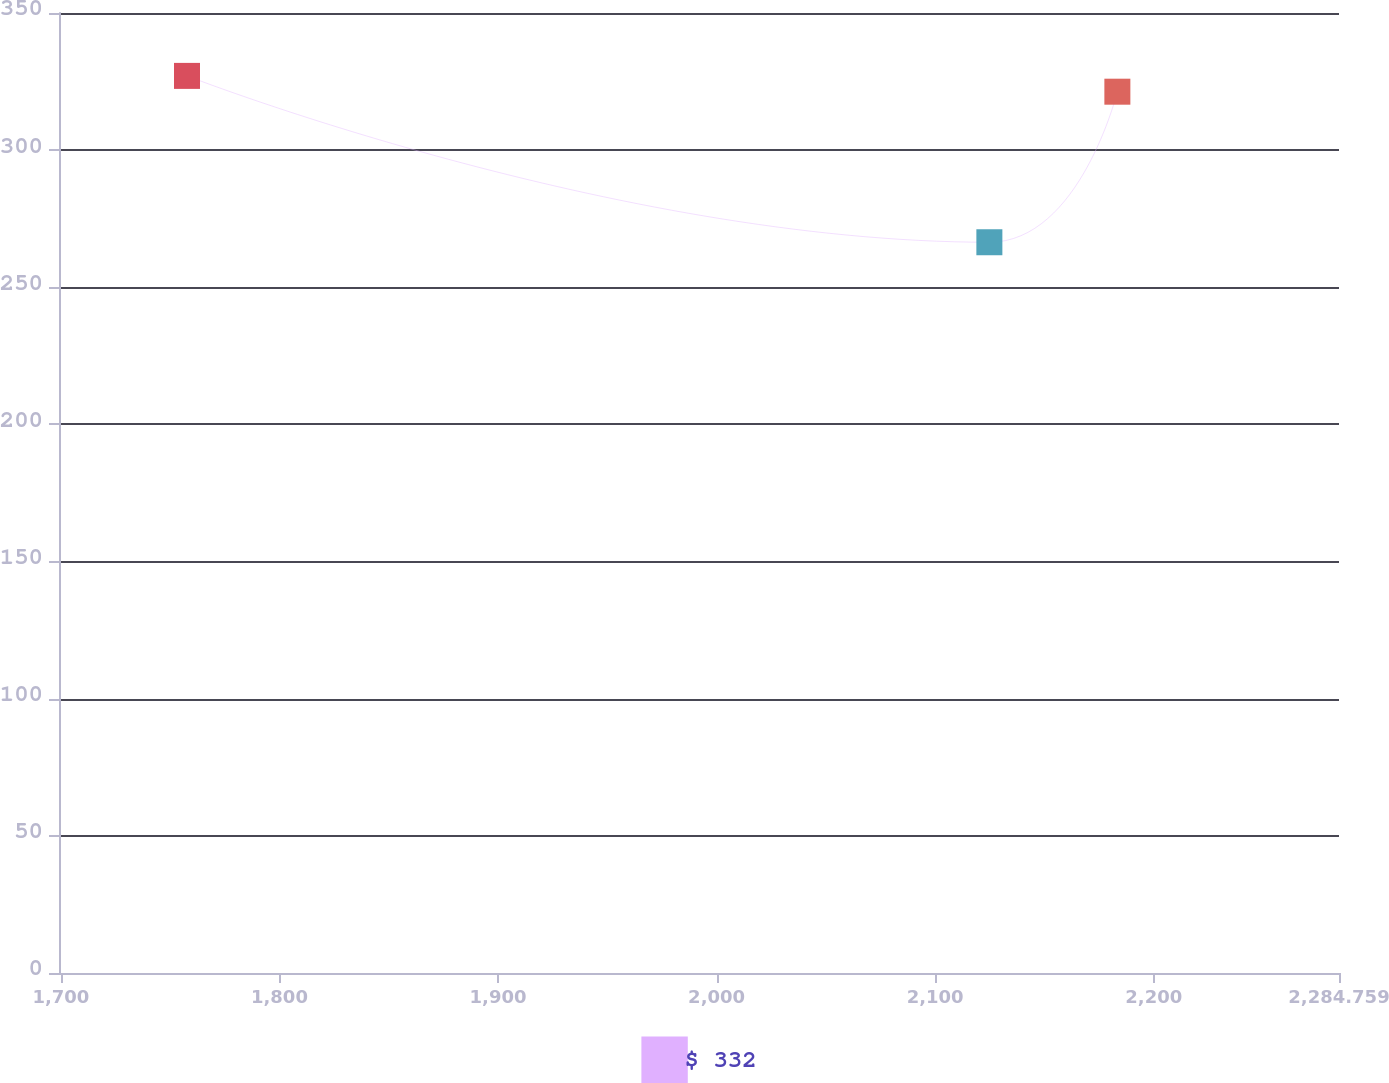Convert chart to OTSL. <chart><loc_0><loc_0><loc_500><loc_500><line_chart><ecel><fcel>$ 332<nl><fcel>1757.71<fcel>327.07<nl><fcel>2124.8<fcel>266.42<nl><fcel>2183.36<fcel>321.31<nl><fcel>2343.32<fcel>305.11<nl></chart> 